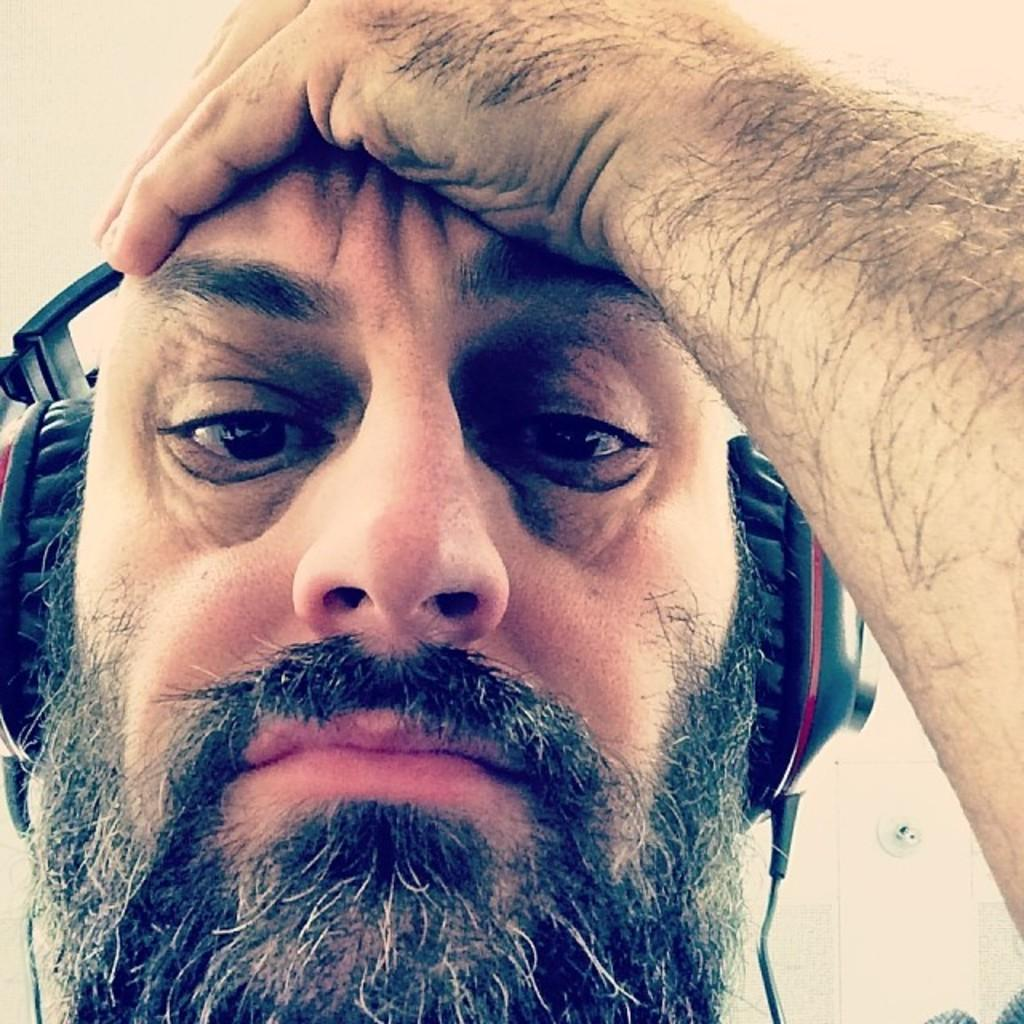What is the main subject of the image? The main subject of the image is a man's face. What can be seen on the man's head in the image? The man is wearing a headphone in the image. What type of pan is being used to create harmony in the image? There is no pan or any indication of creating harmony in the image; it only features a man's face with a headphone. 